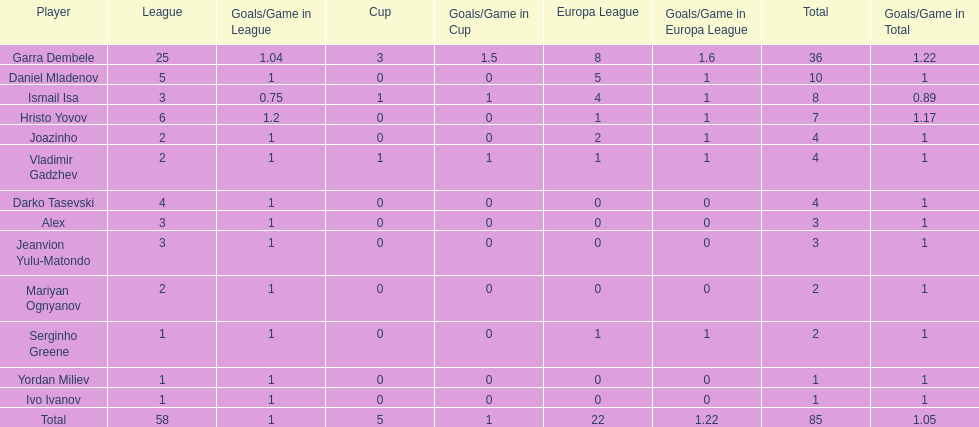Can you list the players with only one goal to their name? Serginho Greene, Yordan Miliev, Ivo Ivanov. 